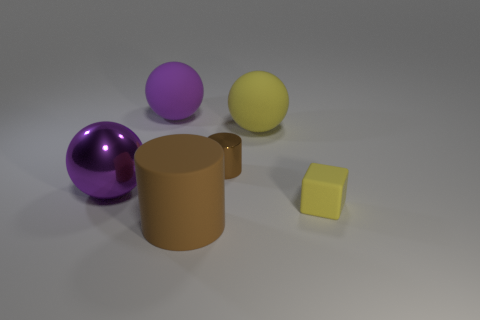Subtract all purple metallic spheres. How many spheres are left? 2 Subtract all blue cubes. How many purple balls are left? 2 Add 2 blue blocks. How many objects exist? 8 Add 1 blocks. How many blocks exist? 2 Subtract 0 brown blocks. How many objects are left? 6 Subtract all blocks. How many objects are left? 5 Subtract all green spheres. Subtract all cyan cubes. How many spheres are left? 3 Subtract all big brown rubber cylinders. Subtract all large purple balls. How many objects are left? 3 Add 4 cylinders. How many cylinders are left? 6 